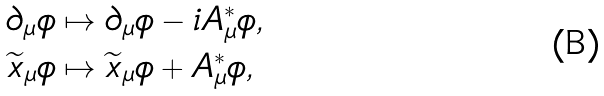<formula> <loc_0><loc_0><loc_500><loc_500>\partial _ { \mu } \phi & \mapsto \partial _ { \mu } \phi - i A _ { \mu } ^ { * } \phi , \\ \widetilde { x } _ { \mu } \phi & \mapsto \widetilde { x } _ { \mu } \phi + A _ { \mu } ^ { * } \phi ,</formula> 